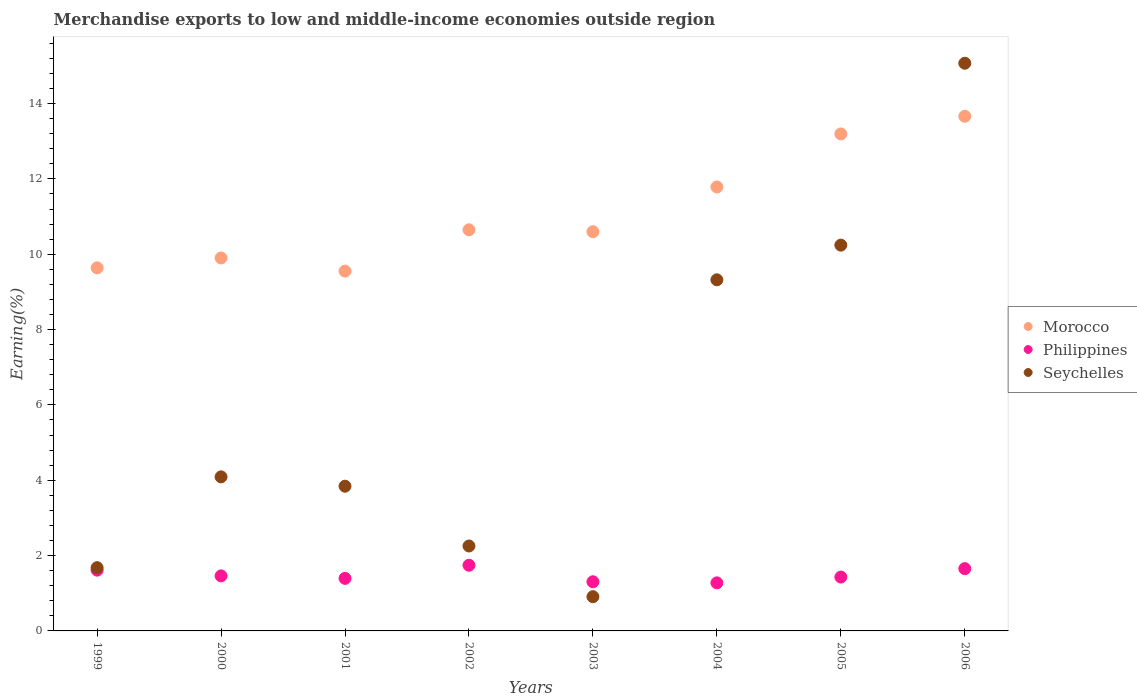What is the percentage of amount earned from merchandise exports in Morocco in 2004?
Provide a short and direct response. 11.78. Across all years, what is the maximum percentage of amount earned from merchandise exports in Philippines?
Provide a succinct answer. 1.74. Across all years, what is the minimum percentage of amount earned from merchandise exports in Morocco?
Ensure brevity in your answer.  9.55. In which year was the percentage of amount earned from merchandise exports in Morocco maximum?
Keep it short and to the point. 2006. In which year was the percentage of amount earned from merchandise exports in Morocco minimum?
Your answer should be compact. 2001. What is the total percentage of amount earned from merchandise exports in Philippines in the graph?
Your response must be concise. 11.88. What is the difference between the percentage of amount earned from merchandise exports in Philippines in 1999 and that in 2000?
Offer a terse response. 0.15. What is the difference between the percentage of amount earned from merchandise exports in Morocco in 2004 and the percentage of amount earned from merchandise exports in Seychelles in 2002?
Ensure brevity in your answer.  9.53. What is the average percentage of amount earned from merchandise exports in Morocco per year?
Make the answer very short. 11.12. In the year 1999, what is the difference between the percentage of amount earned from merchandise exports in Seychelles and percentage of amount earned from merchandise exports in Philippines?
Your response must be concise. 0.07. In how many years, is the percentage of amount earned from merchandise exports in Philippines greater than 10.4 %?
Ensure brevity in your answer.  0. What is the ratio of the percentage of amount earned from merchandise exports in Seychelles in 2003 to that in 2005?
Your response must be concise. 0.09. What is the difference between the highest and the second highest percentage of amount earned from merchandise exports in Philippines?
Ensure brevity in your answer.  0.09. What is the difference between the highest and the lowest percentage of amount earned from merchandise exports in Seychelles?
Offer a very short reply. 14.16. Is the sum of the percentage of amount earned from merchandise exports in Seychelles in 1999 and 2000 greater than the maximum percentage of amount earned from merchandise exports in Morocco across all years?
Keep it short and to the point. No. Is it the case that in every year, the sum of the percentage of amount earned from merchandise exports in Philippines and percentage of amount earned from merchandise exports in Morocco  is greater than the percentage of amount earned from merchandise exports in Seychelles?
Provide a succinct answer. Yes. Is the percentage of amount earned from merchandise exports in Philippines strictly greater than the percentage of amount earned from merchandise exports in Morocco over the years?
Provide a succinct answer. No. Does the graph contain any zero values?
Ensure brevity in your answer.  No. Where does the legend appear in the graph?
Your response must be concise. Center right. What is the title of the graph?
Your answer should be compact. Merchandise exports to low and middle-income economies outside region. Does "Guinea" appear as one of the legend labels in the graph?
Ensure brevity in your answer.  No. What is the label or title of the Y-axis?
Give a very brief answer. Earning(%). What is the Earning(%) of Morocco in 1999?
Make the answer very short. 9.64. What is the Earning(%) of Philippines in 1999?
Provide a succinct answer. 1.61. What is the Earning(%) of Seychelles in 1999?
Provide a succinct answer. 1.68. What is the Earning(%) in Morocco in 2000?
Your answer should be very brief. 9.9. What is the Earning(%) in Philippines in 2000?
Make the answer very short. 1.46. What is the Earning(%) of Seychelles in 2000?
Provide a short and direct response. 4.09. What is the Earning(%) of Morocco in 2001?
Offer a very short reply. 9.55. What is the Earning(%) of Philippines in 2001?
Make the answer very short. 1.4. What is the Earning(%) in Seychelles in 2001?
Provide a short and direct response. 3.84. What is the Earning(%) of Morocco in 2002?
Your answer should be compact. 10.65. What is the Earning(%) of Philippines in 2002?
Make the answer very short. 1.74. What is the Earning(%) in Seychelles in 2002?
Offer a terse response. 2.25. What is the Earning(%) of Morocco in 2003?
Offer a very short reply. 10.6. What is the Earning(%) of Philippines in 2003?
Make the answer very short. 1.3. What is the Earning(%) of Seychelles in 2003?
Provide a short and direct response. 0.91. What is the Earning(%) of Morocco in 2004?
Offer a terse response. 11.78. What is the Earning(%) in Philippines in 2004?
Your answer should be compact. 1.28. What is the Earning(%) in Seychelles in 2004?
Your answer should be compact. 9.32. What is the Earning(%) of Morocco in 2005?
Your response must be concise. 13.19. What is the Earning(%) of Philippines in 2005?
Make the answer very short. 1.43. What is the Earning(%) of Seychelles in 2005?
Your answer should be very brief. 10.24. What is the Earning(%) in Morocco in 2006?
Provide a short and direct response. 13.66. What is the Earning(%) in Philippines in 2006?
Offer a very short reply. 1.65. What is the Earning(%) in Seychelles in 2006?
Provide a succinct answer. 15.07. Across all years, what is the maximum Earning(%) in Morocco?
Make the answer very short. 13.66. Across all years, what is the maximum Earning(%) of Philippines?
Give a very brief answer. 1.74. Across all years, what is the maximum Earning(%) in Seychelles?
Offer a terse response. 15.07. Across all years, what is the minimum Earning(%) of Morocco?
Provide a succinct answer. 9.55. Across all years, what is the minimum Earning(%) in Philippines?
Make the answer very short. 1.28. Across all years, what is the minimum Earning(%) of Seychelles?
Offer a terse response. 0.91. What is the total Earning(%) in Morocco in the graph?
Your answer should be compact. 88.97. What is the total Earning(%) of Philippines in the graph?
Provide a short and direct response. 11.88. What is the total Earning(%) in Seychelles in the graph?
Provide a short and direct response. 47.41. What is the difference between the Earning(%) of Morocco in 1999 and that in 2000?
Keep it short and to the point. -0.26. What is the difference between the Earning(%) in Philippines in 1999 and that in 2000?
Your answer should be very brief. 0.15. What is the difference between the Earning(%) in Seychelles in 1999 and that in 2000?
Provide a short and direct response. -2.41. What is the difference between the Earning(%) of Morocco in 1999 and that in 2001?
Offer a very short reply. 0.09. What is the difference between the Earning(%) in Philippines in 1999 and that in 2001?
Ensure brevity in your answer.  0.22. What is the difference between the Earning(%) of Seychelles in 1999 and that in 2001?
Ensure brevity in your answer.  -2.16. What is the difference between the Earning(%) of Morocco in 1999 and that in 2002?
Provide a short and direct response. -1.01. What is the difference between the Earning(%) in Philippines in 1999 and that in 2002?
Your response must be concise. -0.13. What is the difference between the Earning(%) in Seychelles in 1999 and that in 2002?
Keep it short and to the point. -0.58. What is the difference between the Earning(%) of Morocco in 1999 and that in 2003?
Your answer should be compact. -0.96. What is the difference between the Earning(%) in Philippines in 1999 and that in 2003?
Offer a terse response. 0.31. What is the difference between the Earning(%) in Seychelles in 1999 and that in 2003?
Provide a short and direct response. 0.77. What is the difference between the Earning(%) in Morocco in 1999 and that in 2004?
Ensure brevity in your answer.  -2.15. What is the difference between the Earning(%) of Philippines in 1999 and that in 2004?
Give a very brief answer. 0.34. What is the difference between the Earning(%) of Seychelles in 1999 and that in 2004?
Give a very brief answer. -7.64. What is the difference between the Earning(%) in Morocco in 1999 and that in 2005?
Give a very brief answer. -3.56. What is the difference between the Earning(%) in Philippines in 1999 and that in 2005?
Keep it short and to the point. 0.18. What is the difference between the Earning(%) in Seychelles in 1999 and that in 2005?
Your answer should be very brief. -8.56. What is the difference between the Earning(%) in Morocco in 1999 and that in 2006?
Offer a very short reply. -4.02. What is the difference between the Earning(%) of Philippines in 1999 and that in 2006?
Offer a very short reply. -0.04. What is the difference between the Earning(%) in Seychelles in 1999 and that in 2006?
Ensure brevity in your answer.  -13.39. What is the difference between the Earning(%) of Morocco in 2000 and that in 2001?
Make the answer very short. 0.35. What is the difference between the Earning(%) in Philippines in 2000 and that in 2001?
Your answer should be compact. 0.07. What is the difference between the Earning(%) of Seychelles in 2000 and that in 2001?
Make the answer very short. 0.25. What is the difference between the Earning(%) in Morocco in 2000 and that in 2002?
Your response must be concise. -0.75. What is the difference between the Earning(%) in Philippines in 2000 and that in 2002?
Offer a very short reply. -0.28. What is the difference between the Earning(%) in Seychelles in 2000 and that in 2002?
Give a very brief answer. 1.84. What is the difference between the Earning(%) of Morocco in 2000 and that in 2003?
Offer a terse response. -0.7. What is the difference between the Earning(%) in Philippines in 2000 and that in 2003?
Make the answer very short. 0.16. What is the difference between the Earning(%) of Seychelles in 2000 and that in 2003?
Provide a succinct answer. 3.18. What is the difference between the Earning(%) of Morocco in 2000 and that in 2004?
Give a very brief answer. -1.88. What is the difference between the Earning(%) in Philippines in 2000 and that in 2004?
Your answer should be compact. 0.19. What is the difference between the Earning(%) in Seychelles in 2000 and that in 2004?
Give a very brief answer. -5.23. What is the difference between the Earning(%) of Morocco in 2000 and that in 2005?
Your answer should be compact. -3.29. What is the difference between the Earning(%) of Philippines in 2000 and that in 2005?
Provide a short and direct response. 0.03. What is the difference between the Earning(%) of Seychelles in 2000 and that in 2005?
Provide a succinct answer. -6.15. What is the difference between the Earning(%) of Morocco in 2000 and that in 2006?
Keep it short and to the point. -3.76. What is the difference between the Earning(%) of Philippines in 2000 and that in 2006?
Offer a very short reply. -0.19. What is the difference between the Earning(%) in Seychelles in 2000 and that in 2006?
Make the answer very short. -10.98. What is the difference between the Earning(%) in Morocco in 2001 and that in 2002?
Your answer should be compact. -1.1. What is the difference between the Earning(%) of Philippines in 2001 and that in 2002?
Your response must be concise. -0.35. What is the difference between the Earning(%) in Seychelles in 2001 and that in 2002?
Make the answer very short. 1.59. What is the difference between the Earning(%) of Morocco in 2001 and that in 2003?
Provide a short and direct response. -1.05. What is the difference between the Earning(%) in Philippines in 2001 and that in 2003?
Give a very brief answer. 0.09. What is the difference between the Earning(%) in Seychelles in 2001 and that in 2003?
Make the answer very short. 2.93. What is the difference between the Earning(%) in Morocco in 2001 and that in 2004?
Give a very brief answer. -2.23. What is the difference between the Earning(%) of Philippines in 2001 and that in 2004?
Provide a succinct answer. 0.12. What is the difference between the Earning(%) in Seychelles in 2001 and that in 2004?
Provide a succinct answer. -5.48. What is the difference between the Earning(%) of Morocco in 2001 and that in 2005?
Keep it short and to the point. -3.64. What is the difference between the Earning(%) of Philippines in 2001 and that in 2005?
Offer a very short reply. -0.04. What is the difference between the Earning(%) of Seychelles in 2001 and that in 2005?
Make the answer very short. -6.4. What is the difference between the Earning(%) in Morocco in 2001 and that in 2006?
Provide a succinct answer. -4.11. What is the difference between the Earning(%) in Philippines in 2001 and that in 2006?
Your answer should be compact. -0.26. What is the difference between the Earning(%) in Seychelles in 2001 and that in 2006?
Offer a very short reply. -11.23. What is the difference between the Earning(%) of Morocco in 2002 and that in 2003?
Provide a short and direct response. 0.05. What is the difference between the Earning(%) in Philippines in 2002 and that in 2003?
Keep it short and to the point. 0.44. What is the difference between the Earning(%) of Seychelles in 2002 and that in 2003?
Offer a very short reply. 1.35. What is the difference between the Earning(%) in Morocco in 2002 and that in 2004?
Provide a short and direct response. -1.14. What is the difference between the Earning(%) of Philippines in 2002 and that in 2004?
Provide a short and direct response. 0.47. What is the difference between the Earning(%) in Seychelles in 2002 and that in 2004?
Keep it short and to the point. -7.07. What is the difference between the Earning(%) of Morocco in 2002 and that in 2005?
Provide a succinct answer. -2.54. What is the difference between the Earning(%) in Philippines in 2002 and that in 2005?
Offer a terse response. 0.31. What is the difference between the Earning(%) of Seychelles in 2002 and that in 2005?
Your answer should be compact. -7.99. What is the difference between the Earning(%) in Morocco in 2002 and that in 2006?
Provide a succinct answer. -3.01. What is the difference between the Earning(%) of Philippines in 2002 and that in 2006?
Keep it short and to the point. 0.09. What is the difference between the Earning(%) of Seychelles in 2002 and that in 2006?
Give a very brief answer. -12.81. What is the difference between the Earning(%) in Morocco in 2003 and that in 2004?
Offer a terse response. -1.19. What is the difference between the Earning(%) of Philippines in 2003 and that in 2004?
Your response must be concise. 0.03. What is the difference between the Earning(%) in Seychelles in 2003 and that in 2004?
Keep it short and to the point. -8.41. What is the difference between the Earning(%) of Morocco in 2003 and that in 2005?
Offer a terse response. -2.6. What is the difference between the Earning(%) in Philippines in 2003 and that in 2005?
Your response must be concise. -0.13. What is the difference between the Earning(%) of Seychelles in 2003 and that in 2005?
Your response must be concise. -9.33. What is the difference between the Earning(%) of Morocco in 2003 and that in 2006?
Ensure brevity in your answer.  -3.06. What is the difference between the Earning(%) in Philippines in 2003 and that in 2006?
Provide a short and direct response. -0.35. What is the difference between the Earning(%) in Seychelles in 2003 and that in 2006?
Offer a very short reply. -14.16. What is the difference between the Earning(%) in Morocco in 2004 and that in 2005?
Provide a short and direct response. -1.41. What is the difference between the Earning(%) in Philippines in 2004 and that in 2005?
Provide a short and direct response. -0.15. What is the difference between the Earning(%) in Seychelles in 2004 and that in 2005?
Offer a terse response. -0.92. What is the difference between the Earning(%) in Morocco in 2004 and that in 2006?
Provide a short and direct response. -1.88. What is the difference between the Earning(%) of Philippines in 2004 and that in 2006?
Your answer should be very brief. -0.38. What is the difference between the Earning(%) in Seychelles in 2004 and that in 2006?
Ensure brevity in your answer.  -5.75. What is the difference between the Earning(%) in Morocco in 2005 and that in 2006?
Provide a succinct answer. -0.47. What is the difference between the Earning(%) in Philippines in 2005 and that in 2006?
Offer a very short reply. -0.22. What is the difference between the Earning(%) in Seychelles in 2005 and that in 2006?
Offer a very short reply. -4.83. What is the difference between the Earning(%) of Morocco in 1999 and the Earning(%) of Philippines in 2000?
Offer a very short reply. 8.18. What is the difference between the Earning(%) in Morocco in 1999 and the Earning(%) in Seychelles in 2000?
Ensure brevity in your answer.  5.55. What is the difference between the Earning(%) in Philippines in 1999 and the Earning(%) in Seychelles in 2000?
Keep it short and to the point. -2.48. What is the difference between the Earning(%) of Morocco in 1999 and the Earning(%) of Philippines in 2001?
Ensure brevity in your answer.  8.24. What is the difference between the Earning(%) of Morocco in 1999 and the Earning(%) of Seychelles in 2001?
Your response must be concise. 5.8. What is the difference between the Earning(%) of Philippines in 1999 and the Earning(%) of Seychelles in 2001?
Offer a terse response. -2.23. What is the difference between the Earning(%) in Morocco in 1999 and the Earning(%) in Philippines in 2002?
Make the answer very short. 7.9. What is the difference between the Earning(%) in Morocco in 1999 and the Earning(%) in Seychelles in 2002?
Make the answer very short. 7.38. What is the difference between the Earning(%) in Philippines in 1999 and the Earning(%) in Seychelles in 2002?
Offer a terse response. -0.64. What is the difference between the Earning(%) of Morocco in 1999 and the Earning(%) of Philippines in 2003?
Make the answer very short. 8.33. What is the difference between the Earning(%) of Morocco in 1999 and the Earning(%) of Seychelles in 2003?
Offer a very short reply. 8.73. What is the difference between the Earning(%) of Philippines in 1999 and the Earning(%) of Seychelles in 2003?
Your answer should be compact. 0.7. What is the difference between the Earning(%) in Morocco in 1999 and the Earning(%) in Philippines in 2004?
Your answer should be compact. 8.36. What is the difference between the Earning(%) of Morocco in 1999 and the Earning(%) of Seychelles in 2004?
Provide a short and direct response. 0.32. What is the difference between the Earning(%) in Philippines in 1999 and the Earning(%) in Seychelles in 2004?
Give a very brief answer. -7.71. What is the difference between the Earning(%) of Morocco in 1999 and the Earning(%) of Philippines in 2005?
Your response must be concise. 8.21. What is the difference between the Earning(%) in Morocco in 1999 and the Earning(%) in Seychelles in 2005?
Keep it short and to the point. -0.6. What is the difference between the Earning(%) in Philippines in 1999 and the Earning(%) in Seychelles in 2005?
Your answer should be compact. -8.63. What is the difference between the Earning(%) of Morocco in 1999 and the Earning(%) of Philippines in 2006?
Offer a very short reply. 7.98. What is the difference between the Earning(%) in Morocco in 1999 and the Earning(%) in Seychelles in 2006?
Your answer should be compact. -5.43. What is the difference between the Earning(%) of Philippines in 1999 and the Earning(%) of Seychelles in 2006?
Provide a short and direct response. -13.46. What is the difference between the Earning(%) in Morocco in 2000 and the Earning(%) in Philippines in 2001?
Offer a terse response. 8.51. What is the difference between the Earning(%) of Morocco in 2000 and the Earning(%) of Seychelles in 2001?
Your answer should be compact. 6.06. What is the difference between the Earning(%) of Philippines in 2000 and the Earning(%) of Seychelles in 2001?
Keep it short and to the point. -2.38. What is the difference between the Earning(%) in Morocco in 2000 and the Earning(%) in Philippines in 2002?
Ensure brevity in your answer.  8.16. What is the difference between the Earning(%) of Morocco in 2000 and the Earning(%) of Seychelles in 2002?
Your answer should be compact. 7.65. What is the difference between the Earning(%) in Philippines in 2000 and the Earning(%) in Seychelles in 2002?
Ensure brevity in your answer.  -0.79. What is the difference between the Earning(%) in Morocco in 2000 and the Earning(%) in Philippines in 2003?
Provide a short and direct response. 8.6. What is the difference between the Earning(%) of Morocco in 2000 and the Earning(%) of Seychelles in 2003?
Make the answer very short. 8.99. What is the difference between the Earning(%) of Philippines in 2000 and the Earning(%) of Seychelles in 2003?
Keep it short and to the point. 0.55. What is the difference between the Earning(%) in Morocco in 2000 and the Earning(%) in Philippines in 2004?
Your answer should be compact. 8.62. What is the difference between the Earning(%) in Morocco in 2000 and the Earning(%) in Seychelles in 2004?
Your answer should be compact. 0.58. What is the difference between the Earning(%) of Philippines in 2000 and the Earning(%) of Seychelles in 2004?
Make the answer very short. -7.86. What is the difference between the Earning(%) of Morocco in 2000 and the Earning(%) of Philippines in 2005?
Offer a terse response. 8.47. What is the difference between the Earning(%) in Morocco in 2000 and the Earning(%) in Seychelles in 2005?
Make the answer very short. -0.34. What is the difference between the Earning(%) of Philippines in 2000 and the Earning(%) of Seychelles in 2005?
Your answer should be compact. -8.78. What is the difference between the Earning(%) of Morocco in 2000 and the Earning(%) of Philippines in 2006?
Your answer should be very brief. 8.25. What is the difference between the Earning(%) in Morocco in 2000 and the Earning(%) in Seychelles in 2006?
Your answer should be very brief. -5.17. What is the difference between the Earning(%) of Philippines in 2000 and the Earning(%) of Seychelles in 2006?
Your answer should be very brief. -13.61. What is the difference between the Earning(%) of Morocco in 2001 and the Earning(%) of Philippines in 2002?
Ensure brevity in your answer.  7.81. What is the difference between the Earning(%) in Morocco in 2001 and the Earning(%) in Seychelles in 2002?
Ensure brevity in your answer.  7.3. What is the difference between the Earning(%) in Philippines in 2001 and the Earning(%) in Seychelles in 2002?
Provide a short and direct response. -0.86. What is the difference between the Earning(%) of Morocco in 2001 and the Earning(%) of Philippines in 2003?
Provide a short and direct response. 8.25. What is the difference between the Earning(%) of Morocco in 2001 and the Earning(%) of Seychelles in 2003?
Ensure brevity in your answer.  8.64. What is the difference between the Earning(%) in Philippines in 2001 and the Earning(%) in Seychelles in 2003?
Make the answer very short. 0.49. What is the difference between the Earning(%) in Morocco in 2001 and the Earning(%) in Philippines in 2004?
Give a very brief answer. 8.28. What is the difference between the Earning(%) in Morocco in 2001 and the Earning(%) in Seychelles in 2004?
Your answer should be compact. 0.23. What is the difference between the Earning(%) of Philippines in 2001 and the Earning(%) of Seychelles in 2004?
Ensure brevity in your answer.  -7.93. What is the difference between the Earning(%) of Morocco in 2001 and the Earning(%) of Philippines in 2005?
Offer a terse response. 8.12. What is the difference between the Earning(%) in Morocco in 2001 and the Earning(%) in Seychelles in 2005?
Provide a succinct answer. -0.69. What is the difference between the Earning(%) of Philippines in 2001 and the Earning(%) of Seychelles in 2005?
Your answer should be compact. -8.85. What is the difference between the Earning(%) in Morocco in 2001 and the Earning(%) in Philippines in 2006?
Provide a succinct answer. 7.9. What is the difference between the Earning(%) of Morocco in 2001 and the Earning(%) of Seychelles in 2006?
Provide a short and direct response. -5.52. What is the difference between the Earning(%) in Philippines in 2001 and the Earning(%) in Seychelles in 2006?
Offer a terse response. -13.67. What is the difference between the Earning(%) of Morocco in 2002 and the Earning(%) of Philippines in 2003?
Your answer should be compact. 9.34. What is the difference between the Earning(%) of Morocco in 2002 and the Earning(%) of Seychelles in 2003?
Your response must be concise. 9.74. What is the difference between the Earning(%) in Philippines in 2002 and the Earning(%) in Seychelles in 2003?
Your response must be concise. 0.83. What is the difference between the Earning(%) of Morocco in 2002 and the Earning(%) of Philippines in 2004?
Your answer should be compact. 9.37. What is the difference between the Earning(%) in Morocco in 2002 and the Earning(%) in Seychelles in 2004?
Make the answer very short. 1.33. What is the difference between the Earning(%) in Philippines in 2002 and the Earning(%) in Seychelles in 2004?
Keep it short and to the point. -7.58. What is the difference between the Earning(%) in Morocco in 2002 and the Earning(%) in Philippines in 2005?
Your response must be concise. 9.22. What is the difference between the Earning(%) in Morocco in 2002 and the Earning(%) in Seychelles in 2005?
Your answer should be compact. 0.41. What is the difference between the Earning(%) of Philippines in 2002 and the Earning(%) of Seychelles in 2005?
Your answer should be very brief. -8.5. What is the difference between the Earning(%) of Morocco in 2002 and the Earning(%) of Philippines in 2006?
Keep it short and to the point. 8.99. What is the difference between the Earning(%) in Morocco in 2002 and the Earning(%) in Seychelles in 2006?
Provide a succinct answer. -4.42. What is the difference between the Earning(%) of Philippines in 2002 and the Earning(%) of Seychelles in 2006?
Ensure brevity in your answer.  -13.33. What is the difference between the Earning(%) in Morocco in 2003 and the Earning(%) in Philippines in 2004?
Provide a succinct answer. 9.32. What is the difference between the Earning(%) of Morocco in 2003 and the Earning(%) of Seychelles in 2004?
Keep it short and to the point. 1.28. What is the difference between the Earning(%) of Philippines in 2003 and the Earning(%) of Seychelles in 2004?
Keep it short and to the point. -8.02. What is the difference between the Earning(%) in Morocco in 2003 and the Earning(%) in Philippines in 2005?
Your response must be concise. 9.17. What is the difference between the Earning(%) in Morocco in 2003 and the Earning(%) in Seychelles in 2005?
Your response must be concise. 0.36. What is the difference between the Earning(%) in Philippines in 2003 and the Earning(%) in Seychelles in 2005?
Provide a short and direct response. -8.94. What is the difference between the Earning(%) of Morocco in 2003 and the Earning(%) of Philippines in 2006?
Your response must be concise. 8.94. What is the difference between the Earning(%) of Morocco in 2003 and the Earning(%) of Seychelles in 2006?
Your answer should be compact. -4.47. What is the difference between the Earning(%) of Philippines in 2003 and the Earning(%) of Seychelles in 2006?
Keep it short and to the point. -13.76. What is the difference between the Earning(%) of Morocco in 2004 and the Earning(%) of Philippines in 2005?
Your response must be concise. 10.35. What is the difference between the Earning(%) of Morocco in 2004 and the Earning(%) of Seychelles in 2005?
Provide a short and direct response. 1.54. What is the difference between the Earning(%) in Philippines in 2004 and the Earning(%) in Seychelles in 2005?
Ensure brevity in your answer.  -8.96. What is the difference between the Earning(%) of Morocco in 2004 and the Earning(%) of Philippines in 2006?
Offer a terse response. 10.13. What is the difference between the Earning(%) in Morocco in 2004 and the Earning(%) in Seychelles in 2006?
Keep it short and to the point. -3.29. What is the difference between the Earning(%) of Philippines in 2004 and the Earning(%) of Seychelles in 2006?
Keep it short and to the point. -13.79. What is the difference between the Earning(%) in Morocco in 2005 and the Earning(%) in Philippines in 2006?
Offer a terse response. 11.54. What is the difference between the Earning(%) in Morocco in 2005 and the Earning(%) in Seychelles in 2006?
Offer a very short reply. -1.88. What is the difference between the Earning(%) of Philippines in 2005 and the Earning(%) of Seychelles in 2006?
Make the answer very short. -13.64. What is the average Earning(%) in Morocco per year?
Offer a very short reply. 11.12. What is the average Earning(%) of Philippines per year?
Give a very brief answer. 1.48. What is the average Earning(%) of Seychelles per year?
Offer a terse response. 5.93. In the year 1999, what is the difference between the Earning(%) of Morocco and Earning(%) of Philippines?
Your answer should be compact. 8.03. In the year 1999, what is the difference between the Earning(%) of Morocco and Earning(%) of Seychelles?
Offer a very short reply. 7.96. In the year 1999, what is the difference between the Earning(%) in Philippines and Earning(%) in Seychelles?
Make the answer very short. -0.07. In the year 2000, what is the difference between the Earning(%) of Morocco and Earning(%) of Philippines?
Offer a very short reply. 8.44. In the year 2000, what is the difference between the Earning(%) of Morocco and Earning(%) of Seychelles?
Your answer should be compact. 5.81. In the year 2000, what is the difference between the Earning(%) in Philippines and Earning(%) in Seychelles?
Your answer should be compact. -2.63. In the year 2001, what is the difference between the Earning(%) of Morocco and Earning(%) of Philippines?
Provide a short and direct response. 8.16. In the year 2001, what is the difference between the Earning(%) in Morocco and Earning(%) in Seychelles?
Your answer should be compact. 5.71. In the year 2001, what is the difference between the Earning(%) in Philippines and Earning(%) in Seychelles?
Keep it short and to the point. -2.45. In the year 2002, what is the difference between the Earning(%) of Morocco and Earning(%) of Philippines?
Your answer should be compact. 8.91. In the year 2002, what is the difference between the Earning(%) in Morocco and Earning(%) in Seychelles?
Keep it short and to the point. 8.39. In the year 2002, what is the difference between the Earning(%) of Philippines and Earning(%) of Seychelles?
Ensure brevity in your answer.  -0.51. In the year 2003, what is the difference between the Earning(%) in Morocco and Earning(%) in Philippines?
Keep it short and to the point. 9.29. In the year 2003, what is the difference between the Earning(%) in Morocco and Earning(%) in Seychelles?
Make the answer very short. 9.69. In the year 2003, what is the difference between the Earning(%) in Philippines and Earning(%) in Seychelles?
Ensure brevity in your answer.  0.4. In the year 2004, what is the difference between the Earning(%) of Morocco and Earning(%) of Philippines?
Offer a terse response. 10.51. In the year 2004, what is the difference between the Earning(%) in Morocco and Earning(%) in Seychelles?
Give a very brief answer. 2.46. In the year 2004, what is the difference between the Earning(%) in Philippines and Earning(%) in Seychelles?
Ensure brevity in your answer.  -8.04. In the year 2005, what is the difference between the Earning(%) in Morocco and Earning(%) in Philippines?
Your answer should be compact. 11.76. In the year 2005, what is the difference between the Earning(%) in Morocco and Earning(%) in Seychelles?
Give a very brief answer. 2.95. In the year 2005, what is the difference between the Earning(%) in Philippines and Earning(%) in Seychelles?
Offer a very short reply. -8.81. In the year 2006, what is the difference between the Earning(%) in Morocco and Earning(%) in Philippines?
Your answer should be compact. 12.01. In the year 2006, what is the difference between the Earning(%) of Morocco and Earning(%) of Seychelles?
Offer a very short reply. -1.41. In the year 2006, what is the difference between the Earning(%) of Philippines and Earning(%) of Seychelles?
Offer a terse response. -13.42. What is the ratio of the Earning(%) of Morocco in 1999 to that in 2000?
Your response must be concise. 0.97. What is the ratio of the Earning(%) in Philippines in 1999 to that in 2000?
Your answer should be very brief. 1.1. What is the ratio of the Earning(%) of Seychelles in 1999 to that in 2000?
Provide a succinct answer. 0.41. What is the ratio of the Earning(%) in Morocco in 1999 to that in 2001?
Provide a succinct answer. 1.01. What is the ratio of the Earning(%) of Philippines in 1999 to that in 2001?
Your response must be concise. 1.16. What is the ratio of the Earning(%) in Seychelles in 1999 to that in 2001?
Provide a succinct answer. 0.44. What is the ratio of the Earning(%) of Morocco in 1999 to that in 2002?
Keep it short and to the point. 0.91. What is the ratio of the Earning(%) of Philippines in 1999 to that in 2002?
Provide a succinct answer. 0.93. What is the ratio of the Earning(%) of Seychelles in 1999 to that in 2002?
Provide a succinct answer. 0.74. What is the ratio of the Earning(%) in Morocco in 1999 to that in 2003?
Provide a succinct answer. 0.91. What is the ratio of the Earning(%) of Philippines in 1999 to that in 2003?
Provide a succinct answer. 1.24. What is the ratio of the Earning(%) of Seychelles in 1999 to that in 2003?
Ensure brevity in your answer.  1.85. What is the ratio of the Earning(%) in Morocco in 1999 to that in 2004?
Make the answer very short. 0.82. What is the ratio of the Earning(%) of Philippines in 1999 to that in 2004?
Offer a very short reply. 1.26. What is the ratio of the Earning(%) of Seychelles in 1999 to that in 2004?
Provide a succinct answer. 0.18. What is the ratio of the Earning(%) in Morocco in 1999 to that in 2005?
Make the answer very short. 0.73. What is the ratio of the Earning(%) in Philippines in 1999 to that in 2005?
Provide a short and direct response. 1.13. What is the ratio of the Earning(%) in Seychelles in 1999 to that in 2005?
Offer a very short reply. 0.16. What is the ratio of the Earning(%) of Morocco in 1999 to that in 2006?
Provide a short and direct response. 0.71. What is the ratio of the Earning(%) of Philippines in 1999 to that in 2006?
Provide a short and direct response. 0.98. What is the ratio of the Earning(%) in Seychelles in 1999 to that in 2006?
Make the answer very short. 0.11. What is the ratio of the Earning(%) in Morocco in 2000 to that in 2001?
Provide a succinct answer. 1.04. What is the ratio of the Earning(%) of Philippines in 2000 to that in 2001?
Your answer should be very brief. 1.05. What is the ratio of the Earning(%) in Seychelles in 2000 to that in 2001?
Make the answer very short. 1.06. What is the ratio of the Earning(%) in Morocco in 2000 to that in 2002?
Your answer should be very brief. 0.93. What is the ratio of the Earning(%) in Philippines in 2000 to that in 2002?
Ensure brevity in your answer.  0.84. What is the ratio of the Earning(%) in Seychelles in 2000 to that in 2002?
Give a very brief answer. 1.81. What is the ratio of the Earning(%) in Morocco in 2000 to that in 2003?
Make the answer very short. 0.93. What is the ratio of the Earning(%) in Philippines in 2000 to that in 2003?
Your answer should be very brief. 1.12. What is the ratio of the Earning(%) in Seychelles in 2000 to that in 2003?
Provide a succinct answer. 4.5. What is the ratio of the Earning(%) of Morocco in 2000 to that in 2004?
Provide a succinct answer. 0.84. What is the ratio of the Earning(%) of Philippines in 2000 to that in 2004?
Make the answer very short. 1.15. What is the ratio of the Earning(%) of Seychelles in 2000 to that in 2004?
Make the answer very short. 0.44. What is the ratio of the Earning(%) in Morocco in 2000 to that in 2005?
Ensure brevity in your answer.  0.75. What is the ratio of the Earning(%) of Philippines in 2000 to that in 2005?
Keep it short and to the point. 1.02. What is the ratio of the Earning(%) in Seychelles in 2000 to that in 2005?
Provide a short and direct response. 0.4. What is the ratio of the Earning(%) in Morocco in 2000 to that in 2006?
Ensure brevity in your answer.  0.72. What is the ratio of the Earning(%) in Philippines in 2000 to that in 2006?
Your answer should be very brief. 0.88. What is the ratio of the Earning(%) of Seychelles in 2000 to that in 2006?
Give a very brief answer. 0.27. What is the ratio of the Earning(%) in Morocco in 2001 to that in 2002?
Keep it short and to the point. 0.9. What is the ratio of the Earning(%) of Philippines in 2001 to that in 2002?
Provide a succinct answer. 0.8. What is the ratio of the Earning(%) in Seychelles in 2001 to that in 2002?
Make the answer very short. 1.7. What is the ratio of the Earning(%) of Morocco in 2001 to that in 2003?
Provide a short and direct response. 0.9. What is the ratio of the Earning(%) in Philippines in 2001 to that in 2003?
Offer a terse response. 1.07. What is the ratio of the Earning(%) of Seychelles in 2001 to that in 2003?
Keep it short and to the point. 4.23. What is the ratio of the Earning(%) of Morocco in 2001 to that in 2004?
Keep it short and to the point. 0.81. What is the ratio of the Earning(%) of Philippines in 2001 to that in 2004?
Ensure brevity in your answer.  1.09. What is the ratio of the Earning(%) of Seychelles in 2001 to that in 2004?
Provide a succinct answer. 0.41. What is the ratio of the Earning(%) in Morocco in 2001 to that in 2005?
Offer a terse response. 0.72. What is the ratio of the Earning(%) in Philippines in 2001 to that in 2005?
Give a very brief answer. 0.98. What is the ratio of the Earning(%) of Seychelles in 2001 to that in 2005?
Make the answer very short. 0.38. What is the ratio of the Earning(%) of Morocco in 2001 to that in 2006?
Provide a short and direct response. 0.7. What is the ratio of the Earning(%) of Philippines in 2001 to that in 2006?
Ensure brevity in your answer.  0.84. What is the ratio of the Earning(%) in Seychelles in 2001 to that in 2006?
Provide a short and direct response. 0.25. What is the ratio of the Earning(%) in Morocco in 2002 to that in 2003?
Your answer should be compact. 1. What is the ratio of the Earning(%) in Philippines in 2002 to that in 2003?
Offer a terse response. 1.34. What is the ratio of the Earning(%) of Seychelles in 2002 to that in 2003?
Your answer should be compact. 2.48. What is the ratio of the Earning(%) in Morocco in 2002 to that in 2004?
Offer a terse response. 0.9. What is the ratio of the Earning(%) of Philippines in 2002 to that in 2004?
Your answer should be compact. 1.37. What is the ratio of the Earning(%) of Seychelles in 2002 to that in 2004?
Make the answer very short. 0.24. What is the ratio of the Earning(%) in Morocco in 2002 to that in 2005?
Keep it short and to the point. 0.81. What is the ratio of the Earning(%) of Philippines in 2002 to that in 2005?
Make the answer very short. 1.22. What is the ratio of the Earning(%) of Seychelles in 2002 to that in 2005?
Your answer should be compact. 0.22. What is the ratio of the Earning(%) in Morocco in 2002 to that in 2006?
Your response must be concise. 0.78. What is the ratio of the Earning(%) in Philippines in 2002 to that in 2006?
Your response must be concise. 1.05. What is the ratio of the Earning(%) of Seychelles in 2002 to that in 2006?
Offer a terse response. 0.15. What is the ratio of the Earning(%) of Morocco in 2003 to that in 2004?
Your answer should be compact. 0.9. What is the ratio of the Earning(%) of Philippines in 2003 to that in 2004?
Your answer should be very brief. 1.02. What is the ratio of the Earning(%) of Seychelles in 2003 to that in 2004?
Make the answer very short. 0.1. What is the ratio of the Earning(%) in Morocco in 2003 to that in 2005?
Your response must be concise. 0.8. What is the ratio of the Earning(%) in Philippines in 2003 to that in 2005?
Your answer should be compact. 0.91. What is the ratio of the Earning(%) in Seychelles in 2003 to that in 2005?
Give a very brief answer. 0.09. What is the ratio of the Earning(%) in Morocco in 2003 to that in 2006?
Give a very brief answer. 0.78. What is the ratio of the Earning(%) of Philippines in 2003 to that in 2006?
Offer a very short reply. 0.79. What is the ratio of the Earning(%) in Seychelles in 2003 to that in 2006?
Make the answer very short. 0.06. What is the ratio of the Earning(%) of Morocco in 2004 to that in 2005?
Give a very brief answer. 0.89. What is the ratio of the Earning(%) in Philippines in 2004 to that in 2005?
Your answer should be compact. 0.89. What is the ratio of the Earning(%) of Seychelles in 2004 to that in 2005?
Your answer should be compact. 0.91. What is the ratio of the Earning(%) in Morocco in 2004 to that in 2006?
Make the answer very short. 0.86. What is the ratio of the Earning(%) of Philippines in 2004 to that in 2006?
Offer a terse response. 0.77. What is the ratio of the Earning(%) of Seychelles in 2004 to that in 2006?
Make the answer very short. 0.62. What is the ratio of the Earning(%) of Morocco in 2005 to that in 2006?
Make the answer very short. 0.97. What is the ratio of the Earning(%) of Philippines in 2005 to that in 2006?
Make the answer very short. 0.86. What is the ratio of the Earning(%) of Seychelles in 2005 to that in 2006?
Give a very brief answer. 0.68. What is the difference between the highest and the second highest Earning(%) of Morocco?
Ensure brevity in your answer.  0.47. What is the difference between the highest and the second highest Earning(%) of Philippines?
Your response must be concise. 0.09. What is the difference between the highest and the second highest Earning(%) of Seychelles?
Ensure brevity in your answer.  4.83. What is the difference between the highest and the lowest Earning(%) of Morocco?
Provide a succinct answer. 4.11. What is the difference between the highest and the lowest Earning(%) of Philippines?
Your answer should be compact. 0.47. What is the difference between the highest and the lowest Earning(%) in Seychelles?
Your answer should be compact. 14.16. 